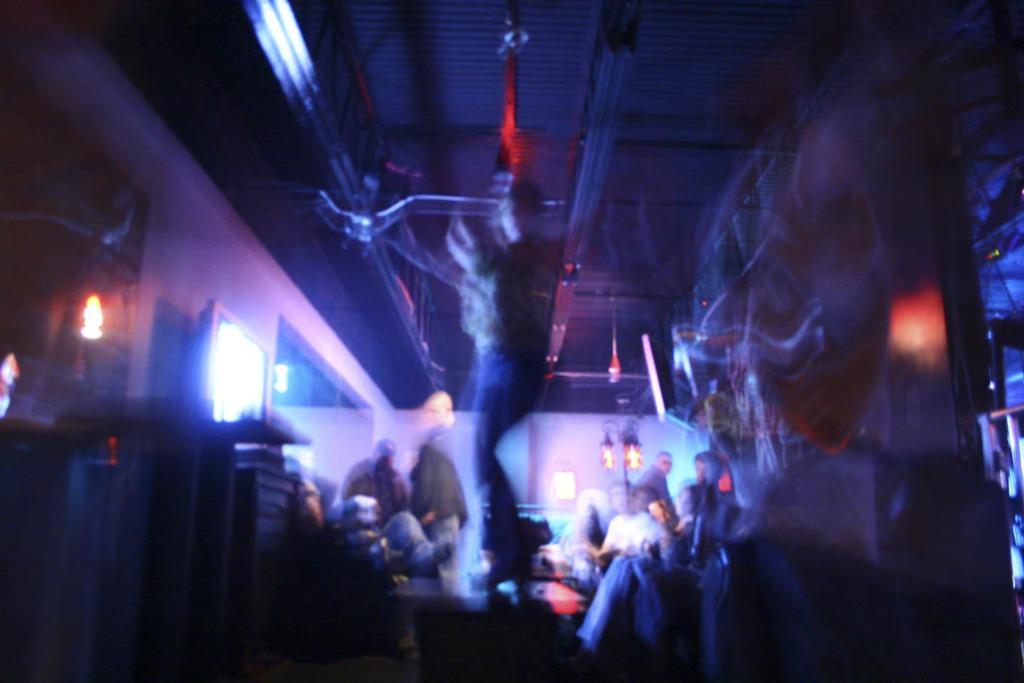In one or two sentences, can you explain what this image depicts? In this image I can see a person standing in the center. Other people are present and there are screens on the either sides. This is a blurred image. 